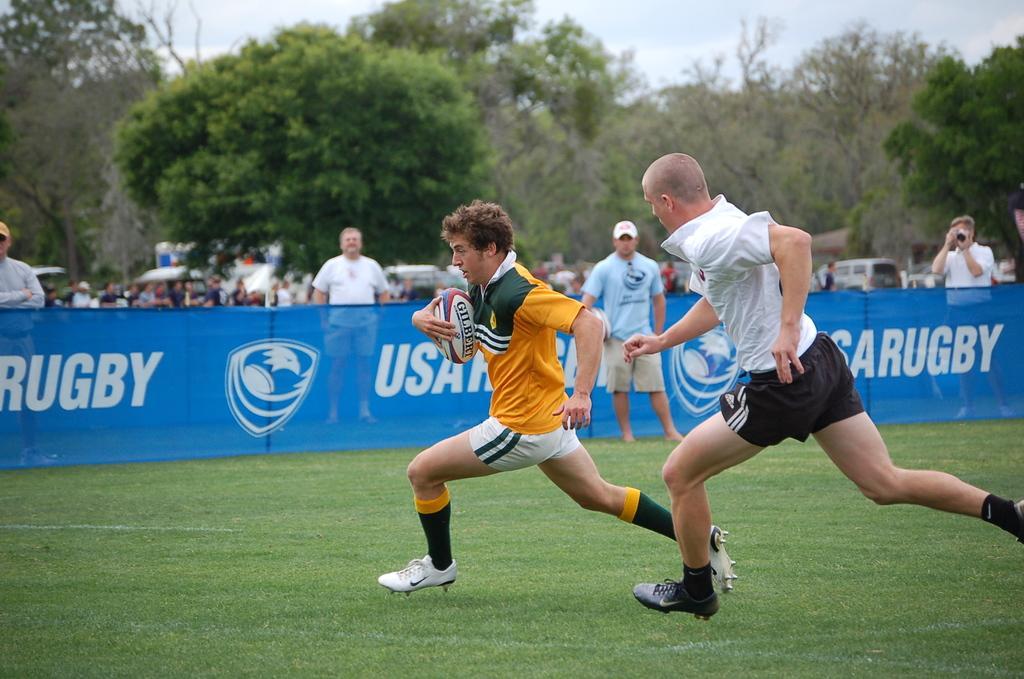Describe this image in one or two sentences. There are two persons running on the ground as we can see at the bottom of this image. The person in the middle is holding a ball. There are some other persons standing in the background. We can see there is a boundary with a cloth in the middle of this image. We can see there are some trees at the top of this image. 